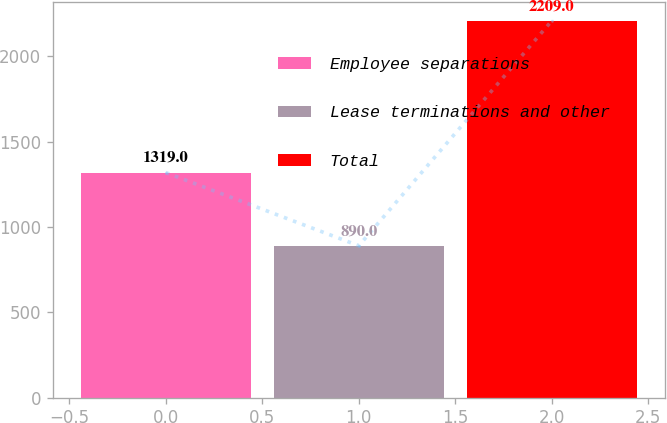Convert chart. <chart><loc_0><loc_0><loc_500><loc_500><bar_chart><fcel>Employee separations<fcel>Lease terminations and other<fcel>Total<nl><fcel>1319<fcel>890<fcel>2209<nl></chart> 